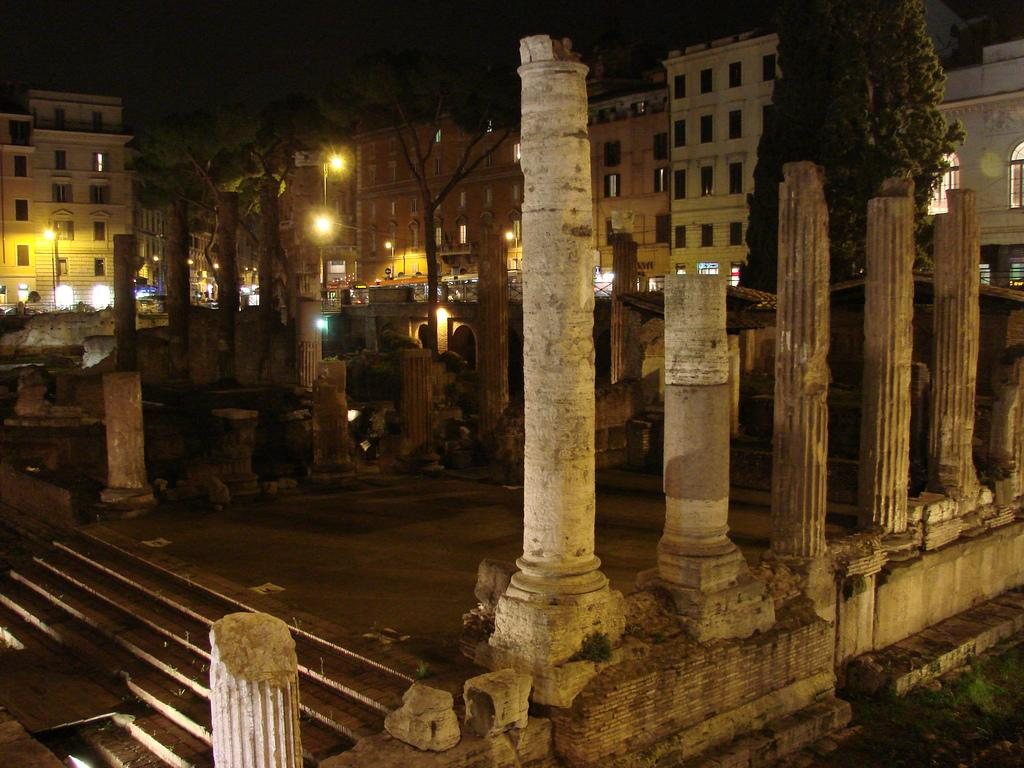What is the main structure in the center of the image? There is a building in the center of the image. What type of natural elements can be seen in the image? Trees are present in the image. What are the vertical structures visible in the image? Poles are visible in the image. What type of illumination is present in the image? Lights are present in the image. What architectural feature can be seen in the image? Stairs are in the image. What part of the natural environment is visible at the top of the image? The sky is visible at the top of the image. What type of surface is present at the bottom right corner of the image? Ground is present at the bottom right corner of the image. What month is it in the image? The image does not provide any information about the month; it only shows the building, trees, poles, lights, stairs, sky, and ground. How many weeks have passed since the competition in the image? There is no competition or reference to time in the image, so it is not possible to determine how many weeks have passed. 